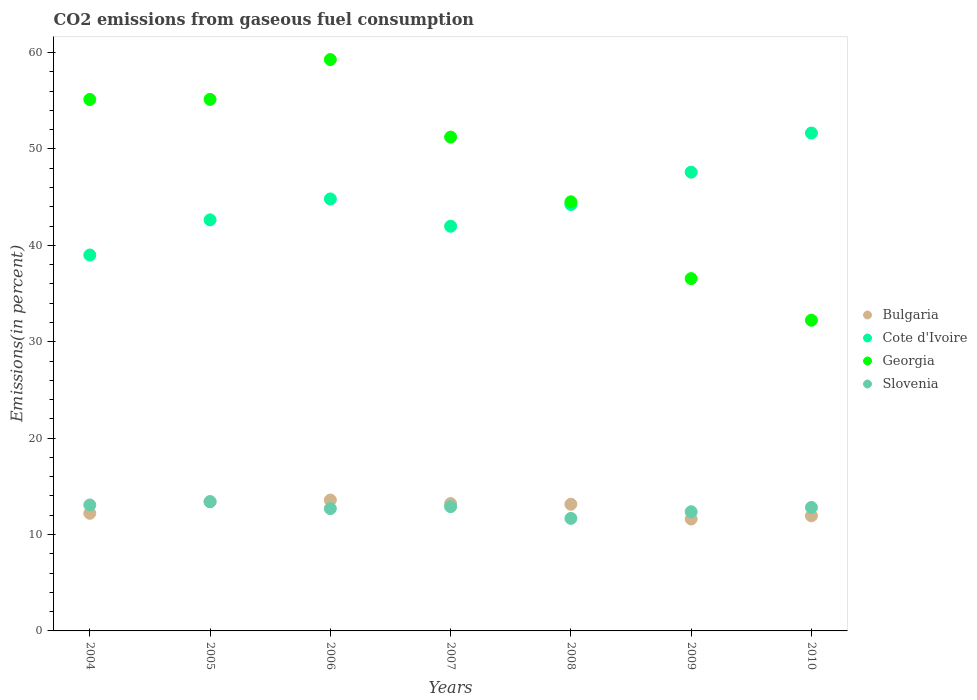What is the total CO2 emitted in Georgia in 2010?
Your answer should be very brief. 32.23. Across all years, what is the maximum total CO2 emitted in Bulgaria?
Your response must be concise. 13.58. Across all years, what is the minimum total CO2 emitted in Slovenia?
Give a very brief answer. 11.67. In which year was the total CO2 emitted in Slovenia maximum?
Give a very brief answer. 2005. What is the total total CO2 emitted in Bulgaria in the graph?
Ensure brevity in your answer.  89.08. What is the difference between the total CO2 emitted in Georgia in 2004 and that in 2008?
Give a very brief answer. 10.62. What is the difference between the total CO2 emitted in Bulgaria in 2004 and the total CO2 emitted in Georgia in 2007?
Your answer should be compact. -39.02. What is the average total CO2 emitted in Cote d'Ivoire per year?
Provide a succinct answer. 44.56. In the year 2010, what is the difference between the total CO2 emitted in Slovenia and total CO2 emitted in Georgia?
Provide a succinct answer. -19.42. What is the ratio of the total CO2 emitted in Bulgaria in 2004 to that in 2010?
Your answer should be very brief. 1.02. Is the total CO2 emitted in Bulgaria in 2005 less than that in 2009?
Give a very brief answer. No. What is the difference between the highest and the second highest total CO2 emitted in Bulgaria?
Provide a succinct answer. 0.17. What is the difference between the highest and the lowest total CO2 emitted in Bulgaria?
Your response must be concise. 1.97. Is it the case that in every year, the sum of the total CO2 emitted in Bulgaria and total CO2 emitted in Georgia  is greater than the total CO2 emitted in Cote d'Ivoire?
Give a very brief answer. No. Is the total CO2 emitted in Cote d'Ivoire strictly less than the total CO2 emitted in Bulgaria over the years?
Provide a short and direct response. No. How many years are there in the graph?
Offer a terse response. 7. Does the graph contain grids?
Ensure brevity in your answer.  No. Where does the legend appear in the graph?
Offer a terse response. Center right. How many legend labels are there?
Offer a very short reply. 4. How are the legend labels stacked?
Offer a terse response. Vertical. What is the title of the graph?
Ensure brevity in your answer.  CO2 emissions from gaseous fuel consumption. Does "Greenland" appear as one of the legend labels in the graph?
Provide a succinct answer. No. What is the label or title of the Y-axis?
Give a very brief answer. Emissions(in percent). What is the Emissions(in percent) in Bulgaria in 2004?
Keep it short and to the point. 12.2. What is the Emissions(in percent) of Cote d'Ivoire in 2004?
Offer a very short reply. 39. What is the Emissions(in percent) in Georgia in 2004?
Offer a very short reply. 55.13. What is the Emissions(in percent) of Slovenia in 2004?
Your response must be concise. 13.06. What is the Emissions(in percent) of Bulgaria in 2005?
Offer a terse response. 13.4. What is the Emissions(in percent) in Cote d'Ivoire in 2005?
Your answer should be very brief. 42.64. What is the Emissions(in percent) of Georgia in 2005?
Keep it short and to the point. 55.14. What is the Emissions(in percent) of Slovenia in 2005?
Offer a very short reply. 13.4. What is the Emissions(in percent) in Bulgaria in 2006?
Keep it short and to the point. 13.58. What is the Emissions(in percent) of Cote d'Ivoire in 2006?
Keep it short and to the point. 44.81. What is the Emissions(in percent) in Georgia in 2006?
Your response must be concise. 59.27. What is the Emissions(in percent) of Slovenia in 2006?
Make the answer very short. 12.69. What is the Emissions(in percent) in Bulgaria in 2007?
Your answer should be very brief. 13.21. What is the Emissions(in percent) in Cote d'Ivoire in 2007?
Ensure brevity in your answer.  41.98. What is the Emissions(in percent) of Georgia in 2007?
Offer a very short reply. 51.23. What is the Emissions(in percent) of Slovenia in 2007?
Make the answer very short. 12.89. What is the Emissions(in percent) of Bulgaria in 2008?
Give a very brief answer. 13.14. What is the Emissions(in percent) of Cote d'Ivoire in 2008?
Offer a very short reply. 44.24. What is the Emissions(in percent) in Georgia in 2008?
Provide a short and direct response. 44.51. What is the Emissions(in percent) of Slovenia in 2008?
Make the answer very short. 11.67. What is the Emissions(in percent) of Bulgaria in 2009?
Provide a short and direct response. 11.61. What is the Emissions(in percent) of Cote d'Ivoire in 2009?
Offer a very short reply. 47.59. What is the Emissions(in percent) in Georgia in 2009?
Make the answer very short. 36.55. What is the Emissions(in percent) of Slovenia in 2009?
Ensure brevity in your answer.  12.36. What is the Emissions(in percent) in Bulgaria in 2010?
Your response must be concise. 11.94. What is the Emissions(in percent) of Cote d'Ivoire in 2010?
Your answer should be very brief. 51.65. What is the Emissions(in percent) in Georgia in 2010?
Provide a succinct answer. 32.23. What is the Emissions(in percent) in Slovenia in 2010?
Your response must be concise. 12.81. Across all years, what is the maximum Emissions(in percent) of Bulgaria?
Offer a very short reply. 13.58. Across all years, what is the maximum Emissions(in percent) in Cote d'Ivoire?
Offer a very short reply. 51.65. Across all years, what is the maximum Emissions(in percent) in Georgia?
Offer a terse response. 59.27. Across all years, what is the maximum Emissions(in percent) in Slovenia?
Ensure brevity in your answer.  13.4. Across all years, what is the minimum Emissions(in percent) of Bulgaria?
Keep it short and to the point. 11.61. Across all years, what is the minimum Emissions(in percent) of Cote d'Ivoire?
Ensure brevity in your answer.  39. Across all years, what is the minimum Emissions(in percent) in Georgia?
Give a very brief answer. 32.23. Across all years, what is the minimum Emissions(in percent) in Slovenia?
Ensure brevity in your answer.  11.67. What is the total Emissions(in percent) in Bulgaria in the graph?
Keep it short and to the point. 89.08. What is the total Emissions(in percent) of Cote d'Ivoire in the graph?
Your response must be concise. 311.91. What is the total Emissions(in percent) in Georgia in the graph?
Keep it short and to the point. 334.06. What is the total Emissions(in percent) of Slovenia in the graph?
Offer a very short reply. 88.89. What is the difference between the Emissions(in percent) of Bulgaria in 2004 and that in 2005?
Offer a very short reply. -1.2. What is the difference between the Emissions(in percent) of Cote d'Ivoire in 2004 and that in 2005?
Ensure brevity in your answer.  -3.65. What is the difference between the Emissions(in percent) of Georgia in 2004 and that in 2005?
Provide a short and direct response. -0.01. What is the difference between the Emissions(in percent) in Slovenia in 2004 and that in 2005?
Provide a succinct answer. -0.34. What is the difference between the Emissions(in percent) in Bulgaria in 2004 and that in 2006?
Your response must be concise. -1.37. What is the difference between the Emissions(in percent) of Cote d'Ivoire in 2004 and that in 2006?
Provide a short and direct response. -5.82. What is the difference between the Emissions(in percent) of Georgia in 2004 and that in 2006?
Your answer should be very brief. -4.14. What is the difference between the Emissions(in percent) in Slovenia in 2004 and that in 2006?
Provide a succinct answer. 0.38. What is the difference between the Emissions(in percent) in Bulgaria in 2004 and that in 2007?
Offer a terse response. -1.01. What is the difference between the Emissions(in percent) in Cote d'Ivoire in 2004 and that in 2007?
Provide a short and direct response. -2.99. What is the difference between the Emissions(in percent) in Georgia in 2004 and that in 2007?
Make the answer very short. 3.9. What is the difference between the Emissions(in percent) in Slovenia in 2004 and that in 2007?
Offer a very short reply. 0.18. What is the difference between the Emissions(in percent) in Bulgaria in 2004 and that in 2008?
Keep it short and to the point. -0.94. What is the difference between the Emissions(in percent) in Cote d'Ivoire in 2004 and that in 2008?
Make the answer very short. -5.24. What is the difference between the Emissions(in percent) of Georgia in 2004 and that in 2008?
Offer a terse response. 10.62. What is the difference between the Emissions(in percent) in Slovenia in 2004 and that in 2008?
Offer a very short reply. 1.39. What is the difference between the Emissions(in percent) in Bulgaria in 2004 and that in 2009?
Provide a succinct answer. 0.6. What is the difference between the Emissions(in percent) in Cote d'Ivoire in 2004 and that in 2009?
Ensure brevity in your answer.  -8.59. What is the difference between the Emissions(in percent) of Georgia in 2004 and that in 2009?
Give a very brief answer. 18.58. What is the difference between the Emissions(in percent) in Slovenia in 2004 and that in 2009?
Make the answer very short. 0.7. What is the difference between the Emissions(in percent) in Bulgaria in 2004 and that in 2010?
Offer a terse response. 0.26. What is the difference between the Emissions(in percent) of Cote d'Ivoire in 2004 and that in 2010?
Keep it short and to the point. -12.66. What is the difference between the Emissions(in percent) in Georgia in 2004 and that in 2010?
Offer a terse response. 22.9. What is the difference between the Emissions(in percent) of Slovenia in 2004 and that in 2010?
Offer a very short reply. 0.25. What is the difference between the Emissions(in percent) of Bulgaria in 2005 and that in 2006?
Your answer should be compact. -0.17. What is the difference between the Emissions(in percent) of Cote d'Ivoire in 2005 and that in 2006?
Your answer should be compact. -2.17. What is the difference between the Emissions(in percent) in Georgia in 2005 and that in 2006?
Offer a very short reply. -4.13. What is the difference between the Emissions(in percent) of Slovenia in 2005 and that in 2006?
Your response must be concise. 0.72. What is the difference between the Emissions(in percent) in Bulgaria in 2005 and that in 2007?
Provide a short and direct response. 0.19. What is the difference between the Emissions(in percent) in Cote d'Ivoire in 2005 and that in 2007?
Your answer should be very brief. 0.66. What is the difference between the Emissions(in percent) of Georgia in 2005 and that in 2007?
Your answer should be compact. 3.91. What is the difference between the Emissions(in percent) in Slovenia in 2005 and that in 2007?
Make the answer very short. 0.51. What is the difference between the Emissions(in percent) in Bulgaria in 2005 and that in 2008?
Your response must be concise. 0.26. What is the difference between the Emissions(in percent) in Cote d'Ivoire in 2005 and that in 2008?
Ensure brevity in your answer.  -1.59. What is the difference between the Emissions(in percent) in Georgia in 2005 and that in 2008?
Your answer should be compact. 10.62. What is the difference between the Emissions(in percent) of Slovenia in 2005 and that in 2008?
Your answer should be compact. 1.73. What is the difference between the Emissions(in percent) in Bulgaria in 2005 and that in 2009?
Offer a terse response. 1.8. What is the difference between the Emissions(in percent) of Cote d'Ivoire in 2005 and that in 2009?
Provide a succinct answer. -4.95. What is the difference between the Emissions(in percent) in Georgia in 2005 and that in 2009?
Your answer should be compact. 18.59. What is the difference between the Emissions(in percent) in Slovenia in 2005 and that in 2009?
Give a very brief answer. 1.04. What is the difference between the Emissions(in percent) of Bulgaria in 2005 and that in 2010?
Offer a very short reply. 1.46. What is the difference between the Emissions(in percent) of Cote d'Ivoire in 2005 and that in 2010?
Your answer should be very brief. -9.01. What is the difference between the Emissions(in percent) of Georgia in 2005 and that in 2010?
Offer a very short reply. 22.91. What is the difference between the Emissions(in percent) of Slovenia in 2005 and that in 2010?
Offer a terse response. 0.59. What is the difference between the Emissions(in percent) of Bulgaria in 2006 and that in 2007?
Make the answer very short. 0.37. What is the difference between the Emissions(in percent) of Cote d'Ivoire in 2006 and that in 2007?
Keep it short and to the point. 2.83. What is the difference between the Emissions(in percent) in Georgia in 2006 and that in 2007?
Keep it short and to the point. 8.04. What is the difference between the Emissions(in percent) in Slovenia in 2006 and that in 2007?
Your response must be concise. -0.2. What is the difference between the Emissions(in percent) of Bulgaria in 2006 and that in 2008?
Give a very brief answer. 0.44. What is the difference between the Emissions(in percent) of Cote d'Ivoire in 2006 and that in 2008?
Ensure brevity in your answer.  0.57. What is the difference between the Emissions(in percent) of Georgia in 2006 and that in 2008?
Your answer should be very brief. 14.76. What is the difference between the Emissions(in percent) of Slovenia in 2006 and that in 2008?
Give a very brief answer. 1.01. What is the difference between the Emissions(in percent) of Bulgaria in 2006 and that in 2009?
Your answer should be very brief. 1.97. What is the difference between the Emissions(in percent) in Cote d'Ivoire in 2006 and that in 2009?
Ensure brevity in your answer.  -2.78. What is the difference between the Emissions(in percent) in Georgia in 2006 and that in 2009?
Your answer should be compact. 22.72. What is the difference between the Emissions(in percent) in Slovenia in 2006 and that in 2009?
Offer a terse response. 0.32. What is the difference between the Emissions(in percent) of Bulgaria in 2006 and that in 2010?
Your answer should be very brief. 1.63. What is the difference between the Emissions(in percent) of Cote d'Ivoire in 2006 and that in 2010?
Provide a short and direct response. -6.84. What is the difference between the Emissions(in percent) of Georgia in 2006 and that in 2010?
Ensure brevity in your answer.  27.04. What is the difference between the Emissions(in percent) in Slovenia in 2006 and that in 2010?
Your answer should be compact. -0.13. What is the difference between the Emissions(in percent) in Bulgaria in 2007 and that in 2008?
Provide a succinct answer. 0.07. What is the difference between the Emissions(in percent) of Cote d'Ivoire in 2007 and that in 2008?
Your answer should be very brief. -2.25. What is the difference between the Emissions(in percent) of Georgia in 2007 and that in 2008?
Offer a terse response. 6.71. What is the difference between the Emissions(in percent) of Slovenia in 2007 and that in 2008?
Provide a succinct answer. 1.22. What is the difference between the Emissions(in percent) in Bulgaria in 2007 and that in 2009?
Ensure brevity in your answer.  1.6. What is the difference between the Emissions(in percent) of Cote d'Ivoire in 2007 and that in 2009?
Give a very brief answer. -5.61. What is the difference between the Emissions(in percent) of Georgia in 2007 and that in 2009?
Ensure brevity in your answer.  14.68. What is the difference between the Emissions(in percent) of Slovenia in 2007 and that in 2009?
Your response must be concise. 0.53. What is the difference between the Emissions(in percent) in Bulgaria in 2007 and that in 2010?
Offer a terse response. 1.27. What is the difference between the Emissions(in percent) of Cote d'Ivoire in 2007 and that in 2010?
Your response must be concise. -9.67. What is the difference between the Emissions(in percent) in Georgia in 2007 and that in 2010?
Offer a very short reply. 19. What is the difference between the Emissions(in percent) of Slovenia in 2007 and that in 2010?
Give a very brief answer. 0.08. What is the difference between the Emissions(in percent) in Bulgaria in 2008 and that in 2009?
Give a very brief answer. 1.53. What is the difference between the Emissions(in percent) in Cote d'Ivoire in 2008 and that in 2009?
Your response must be concise. -3.35. What is the difference between the Emissions(in percent) of Georgia in 2008 and that in 2009?
Your answer should be very brief. 7.96. What is the difference between the Emissions(in percent) of Slovenia in 2008 and that in 2009?
Your response must be concise. -0.69. What is the difference between the Emissions(in percent) of Bulgaria in 2008 and that in 2010?
Your response must be concise. 1.2. What is the difference between the Emissions(in percent) of Cote d'Ivoire in 2008 and that in 2010?
Ensure brevity in your answer.  -7.41. What is the difference between the Emissions(in percent) in Georgia in 2008 and that in 2010?
Give a very brief answer. 12.29. What is the difference between the Emissions(in percent) in Slovenia in 2008 and that in 2010?
Ensure brevity in your answer.  -1.14. What is the difference between the Emissions(in percent) in Bulgaria in 2009 and that in 2010?
Offer a very short reply. -0.34. What is the difference between the Emissions(in percent) of Cote d'Ivoire in 2009 and that in 2010?
Keep it short and to the point. -4.06. What is the difference between the Emissions(in percent) of Georgia in 2009 and that in 2010?
Provide a short and direct response. 4.32. What is the difference between the Emissions(in percent) of Slovenia in 2009 and that in 2010?
Offer a terse response. -0.45. What is the difference between the Emissions(in percent) in Bulgaria in 2004 and the Emissions(in percent) in Cote d'Ivoire in 2005?
Provide a short and direct response. -30.44. What is the difference between the Emissions(in percent) in Bulgaria in 2004 and the Emissions(in percent) in Georgia in 2005?
Provide a short and direct response. -42.93. What is the difference between the Emissions(in percent) in Bulgaria in 2004 and the Emissions(in percent) in Slovenia in 2005?
Keep it short and to the point. -1.2. What is the difference between the Emissions(in percent) of Cote d'Ivoire in 2004 and the Emissions(in percent) of Georgia in 2005?
Your answer should be compact. -16.14. What is the difference between the Emissions(in percent) of Cote d'Ivoire in 2004 and the Emissions(in percent) of Slovenia in 2005?
Your answer should be very brief. 25.59. What is the difference between the Emissions(in percent) of Georgia in 2004 and the Emissions(in percent) of Slovenia in 2005?
Keep it short and to the point. 41.73. What is the difference between the Emissions(in percent) of Bulgaria in 2004 and the Emissions(in percent) of Cote d'Ivoire in 2006?
Offer a very short reply. -32.61. What is the difference between the Emissions(in percent) of Bulgaria in 2004 and the Emissions(in percent) of Georgia in 2006?
Offer a terse response. -47.07. What is the difference between the Emissions(in percent) in Bulgaria in 2004 and the Emissions(in percent) in Slovenia in 2006?
Offer a terse response. -0.48. What is the difference between the Emissions(in percent) of Cote d'Ivoire in 2004 and the Emissions(in percent) of Georgia in 2006?
Keep it short and to the point. -20.28. What is the difference between the Emissions(in percent) of Cote d'Ivoire in 2004 and the Emissions(in percent) of Slovenia in 2006?
Your response must be concise. 26.31. What is the difference between the Emissions(in percent) in Georgia in 2004 and the Emissions(in percent) in Slovenia in 2006?
Keep it short and to the point. 42.45. What is the difference between the Emissions(in percent) in Bulgaria in 2004 and the Emissions(in percent) in Cote d'Ivoire in 2007?
Offer a terse response. -29.78. What is the difference between the Emissions(in percent) in Bulgaria in 2004 and the Emissions(in percent) in Georgia in 2007?
Keep it short and to the point. -39.02. What is the difference between the Emissions(in percent) of Bulgaria in 2004 and the Emissions(in percent) of Slovenia in 2007?
Keep it short and to the point. -0.69. What is the difference between the Emissions(in percent) of Cote d'Ivoire in 2004 and the Emissions(in percent) of Georgia in 2007?
Offer a very short reply. -12.23. What is the difference between the Emissions(in percent) of Cote d'Ivoire in 2004 and the Emissions(in percent) of Slovenia in 2007?
Provide a short and direct response. 26.11. What is the difference between the Emissions(in percent) of Georgia in 2004 and the Emissions(in percent) of Slovenia in 2007?
Your answer should be compact. 42.24. What is the difference between the Emissions(in percent) of Bulgaria in 2004 and the Emissions(in percent) of Cote d'Ivoire in 2008?
Keep it short and to the point. -32.03. What is the difference between the Emissions(in percent) of Bulgaria in 2004 and the Emissions(in percent) of Georgia in 2008?
Offer a terse response. -32.31. What is the difference between the Emissions(in percent) of Bulgaria in 2004 and the Emissions(in percent) of Slovenia in 2008?
Your response must be concise. 0.53. What is the difference between the Emissions(in percent) in Cote d'Ivoire in 2004 and the Emissions(in percent) in Georgia in 2008?
Make the answer very short. -5.52. What is the difference between the Emissions(in percent) of Cote d'Ivoire in 2004 and the Emissions(in percent) of Slovenia in 2008?
Your response must be concise. 27.32. What is the difference between the Emissions(in percent) of Georgia in 2004 and the Emissions(in percent) of Slovenia in 2008?
Your response must be concise. 43.46. What is the difference between the Emissions(in percent) of Bulgaria in 2004 and the Emissions(in percent) of Cote d'Ivoire in 2009?
Your answer should be compact. -35.39. What is the difference between the Emissions(in percent) in Bulgaria in 2004 and the Emissions(in percent) in Georgia in 2009?
Ensure brevity in your answer.  -24.35. What is the difference between the Emissions(in percent) of Bulgaria in 2004 and the Emissions(in percent) of Slovenia in 2009?
Offer a very short reply. -0.16. What is the difference between the Emissions(in percent) in Cote d'Ivoire in 2004 and the Emissions(in percent) in Georgia in 2009?
Your answer should be very brief. 2.45. What is the difference between the Emissions(in percent) of Cote d'Ivoire in 2004 and the Emissions(in percent) of Slovenia in 2009?
Ensure brevity in your answer.  26.63. What is the difference between the Emissions(in percent) of Georgia in 2004 and the Emissions(in percent) of Slovenia in 2009?
Give a very brief answer. 42.77. What is the difference between the Emissions(in percent) in Bulgaria in 2004 and the Emissions(in percent) in Cote d'Ivoire in 2010?
Provide a succinct answer. -39.45. What is the difference between the Emissions(in percent) of Bulgaria in 2004 and the Emissions(in percent) of Georgia in 2010?
Your answer should be compact. -20.03. What is the difference between the Emissions(in percent) of Bulgaria in 2004 and the Emissions(in percent) of Slovenia in 2010?
Keep it short and to the point. -0.61. What is the difference between the Emissions(in percent) in Cote d'Ivoire in 2004 and the Emissions(in percent) in Georgia in 2010?
Provide a short and direct response. 6.77. What is the difference between the Emissions(in percent) in Cote d'Ivoire in 2004 and the Emissions(in percent) in Slovenia in 2010?
Keep it short and to the point. 26.18. What is the difference between the Emissions(in percent) in Georgia in 2004 and the Emissions(in percent) in Slovenia in 2010?
Your response must be concise. 42.32. What is the difference between the Emissions(in percent) in Bulgaria in 2005 and the Emissions(in percent) in Cote d'Ivoire in 2006?
Your answer should be compact. -31.41. What is the difference between the Emissions(in percent) in Bulgaria in 2005 and the Emissions(in percent) in Georgia in 2006?
Provide a succinct answer. -45.87. What is the difference between the Emissions(in percent) of Bulgaria in 2005 and the Emissions(in percent) of Slovenia in 2006?
Keep it short and to the point. 0.72. What is the difference between the Emissions(in percent) of Cote d'Ivoire in 2005 and the Emissions(in percent) of Georgia in 2006?
Provide a short and direct response. -16.63. What is the difference between the Emissions(in percent) of Cote d'Ivoire in 2005 and the Emissions(in percent) of Slovenia in 2006?
Provide a short and direct response. 29.96. What is the difference between the Emissions(in percent) of Georgia in 2005 and the Emissions(in percent) of Slovenia in 2006?
Keep it short and to the point. 42.45. What is the difference between the Emissions(in percent) in Bulgaria in 2005 and the Emissions(in percent) in Cote d'Ivoire in 2007?
Provide a short and direct response. -28.58. What is the difference between the Emissions(in percent) in Bulgaria in 2005 and the Emissions(in percent) in Georgia in 2007?
Give a very brief answer. -37.83. What is the difference between the Emissions(in percent) in Bulgaria in 2005 and the Emissions(in percent) in Slovenia in 2007?
Your response must be concise. 0.51. What is the difference between the Emissions(in percent) of Cote d'Ivoire in 2005 and the Emissions(in percent) of Georgia in 2007?
Provide a succinct answer. -8.58. What is the difference between the Emissions(in percent) of Cote d'Ivoire in 2005 and the Emissions(in percent) of Slovenia in 2007?
Provide a short and direct response. 29.75. What is the difference between the Emissions(in percent) in Georgia in 2005 and the Emissions(in percent) in Slovenia in 2007?
Your response must be concise. 42.25. What is the difference between the Emissions(in percent) in Bulgaria in 2005 and the Emissions(in percent) in Cote d'Ivoire in 2008?
Your answer should be very brief. -30.83. What is the difference between the Emissions(in percent) of Bulgaria in 2005 and the Emissions(in percent) of Georgia in 2008?
Offer a terse response. -31.11. What is the difference between the Emissions(in percent) of Bulgaria in 2005 and the Emissions(in percent) of Slovenia in 2008?
Ensure brevity in your answer.  1.73. What is the difference between the Emissions(in percent) in Cote d'Ivoire in 2005 and the Emissions(in percent) in Georgia in 2008?
Provide a short and direct response. -1.87. What is the difference between the Emissions(in percent) in Cote d'Ivoire in 2005 and the Emissions(in percent) in Slovenia in 2008?
Ensure brevity in your answer.  30.97. What is the difference between the Emissions(in percent) of Georgia in 2005 and the Emissions(in percent) of Slovenia in 2008?
Your answer should be very brief. 43.46. What is the difference between the Emissions(in percent) of Bulgaria in 2005 and the Emissions(in percent) of Cote d'Ivoire in 2009?
Keep it short and to the point. -34.19. What is the difference between the Emissions(in percent) of Bulgaria in 2005 and the Emissions(in percent) of Georgia in 2009?
Provide a short and direct response. -23.15. What is the difference between the Emissions(in percent) of Bulgaria in 2005 and the Emissions(in percent) of Slovenia in 2009?
Provide a short and direct response. 1.04. What is the difference between the Emissions(in percent) of Cote d'Ivoire in 2005 and the Emissions(in percent) of Georgia in 2009?
Keep it short and to the point. 6.09. What is the difference between the Emissions(in percent) in Cote d'Ivoire in 2005 and the Emissions(in percent) in Slovenia in 2009?
Keep it short and to the point. 30.28. What is the difference between the Emissions(in percent) in Georgia in 2005 and the Emissions(in percent) in Slovenia in 2009?
Your answer should be very brief. 42.77. What is the difference between the Emissions(in percent) in Bulgaria in 2005 and the Emissions(in percent) in Cote d'Ivoire in 2010?
Your response must be concise. -38.25. What is the difference between the Emissions(in percent) in Bulgaria in 2005 and the Emissions(in percent) in Georgia in 2010?
Make the answer very short. -18.83. What is the difference between the Emissions(in percent) of Bulgaria in 2005 and the Emissions(in percent) of Slovenia in 2010?
Keep it short and to the point. 0.59. What is the difference between the Emissions(in percent) in Cote d'Ivoire in 2005 and the Emissions(in percent) in Georgia in 2010?
Ensure brevity in your answer.  10.41. What is the difference between the Emissions(in percent) in Cote d'Ivoire in 2005 and the Emissions(in percent) in Slovenia in 2010?
Provide a short and direct response. 29.83. What is the difference between the Emissions(in percent) in Georgia in 2005 and the Emissions(in percent) in Slovenia in 2010?
Offer a very short reply. 42.33. What is the difference between the Emissions(in percent) of Bulgaria in 2006 and the Emissions(in percent) of Cote d'Ivoire in 2007?
Offer a terse response. -28.41. What is the difference between the Emissions(in percent) in Bulgaria in 2006 and the Emissions(in percent) in Georgia in 2007?
Offer a very short reply. -37.65. What is the difference between the Emissions(in percent) of Bulgaria in 2006 and the Emissions(in percent) of Slovenia in 2007?
Offer a very short reply. 0.69. What is the difference between the Emissions(in percent) in Cote d'Ivoire in 2006 and the Emissions(in percent) in Georgia in 2007?
Provide a succinct answer. -6.42. What is the difference between the Emissions(in percent) in Cote d'Ivoire in 2006 and the Emissions(in percent) in Slovenia in 2007?
Provide a short and direct response. 31.92. What is the difference between the Emissions(in percent) in Georgia in 2006 and the Emissions(in percent) in Slovenia in 2007?
Offer a very short reply. 46.38. What is the difference between the Emissions(in percent) of Bulgaria in 2006 and the Emissions(in percent) of Cote d'Ivoire in 2008?
Keep it short and to the point. -30.66. What is the difference between the Emissions(in percent) in Bulgaria in 2006 and the Emissions(in percent) in Georgia in 2008?
Your response must be concise. -30.94. What is the difference between the Emissions(in percent) in Bulgaria in 2006 and the Emissions(in percent) in Slovenia in 2008?
Your answer should be compact. 1.9. What is the difference between the Emissions(in percent) in Cote d'Ivoire in 2006 and the Emissions(in percent) in Georgia in 2008?
Make the answer very short. 0.3. What is the difference between the Emissions(in percent) in Cote d'Ivoire in 2006 and the Emissions(in percent) in Slovenia in 2008?
Your answer should be compact. 33.14. What is the difference between the Emissions(in percent) in Georgia in 2006 and the Emissions(in percent) in Slovenia in 2008?
Give a very brief answer. 47.6. What is the difference between the Emissions(in percent) in Bulgaria in 2006 and the Emissions(in percent) in Cote d'Ivoire in 2009?
Offer a terse response. -34.01. What is the difference between the Emissions(in percent) of Bulgaria in 2006 and the Emissions(in percent) of Georgia in 2009?
Keep it short and to the point. -22.97. What is the difference between the Emissions(in percent) of Bulgaria in 2006 and the Emissions(in percent) of Slovenia in 2009?
Your response must be concise. 1.21. What is the difference between the Emissions(in percent) in Cote d'Ivoire in 2006 and the Emissions(in percent) in Georgia in 2009?
Provide a short and direct response. 8.26. What is the difference between the Emissions(in percent) of Cote d'Ivoire in 2006 and the Emissions(in percent) of Slovenia in 2009?
Your response must be concise. 32.45. What is the difference between the Emissions(in percent) of Georgia in 2006 and the Emissions(in percent) of Slovenia in 2009?
Your answer should be compact. 46.91. What is the difference between the Emissions(in percent) of Bulgaria in 2006 and the Emissions(in percent) of Cote d'Ivoire in 2010?
Make the answer very short. -38.08. What is the difference between the Emissions(in percent) in Bulgaria in 2006 and the Emissions(in percent) in Georgia in 2010?
Ensure brevity in your answer.  -18.65. What is the difference between the Emissions(in percent) of Bulgaria in 2006 and the Emissions(in percent) of Slovenia in 2010?
Your answer should be very brief. 0.76. What is the difference between the Emissions(in percent) of Cote d'Ivoire in 2006 and the Emissions(in percent) of Georgia in 2010?
Keep it short and to the point. 12.58. What is the difference between the Emissions(in percent) in Cote d'Ivoire in 2006 and the Emissions(in percent) in Slovenia in 2010?
Make the answer very short. 32. What is the difference between the Emissions(in percent) in Georgia in 2006 and the Emissions(in percent) in Slovenia in 2010?
Give a very brief answer. 46.46. What is the difference between the Emissions(in percent) of Bulgaria in 2007 and the Emissions(in percent) of Cote d'Ivoire in 2008?
Offer a very short reply. -31.03. What is the difference between the Emissions(in percent) in Bulgaria in 2007 and the Emissions(in percent) in Georgia in 2008?
Make the answer very short. -31.3. What is the difference between the Emissions(in percent) in Bulgaria in 2007 and the Emissions(in percent) in Slovenia in 2008?
Offer a terse response. 1.54. What is the difference between the Emissions(in percent) in Cote d'Ivoire in 2007 and the Emissions(in percent) in Georgia in 2008?
Make the answer very short. -2.53. What is the difference between the Emissions(in percent) in Cote d'Ivoire in 2007 and the Emissions(in percent) in Slovenia in 2008?
Keep it short and to the point. 30.31. What is the difference between the Emissions(in percent) of Georgia in 2007 and the Emissions(in percent) of Slovenia in 2008?
Provide a succinct answer. 39.55. What is the difference between the Emissions(in percent) of Bulgaria in 2007 and the Emissions(in percent) of Cote d'Ivoire in 2009?
Make the answer very short. -34.38. What is the difference between the Emissions(in percent) in Bulgaria in 2007 and the Emissions(in percent) in Georgia in 2009?
Give a very brief answer. -23.34. What is the difference between the Emissions(in percent) in Bulgaria in 2007 and the Emissions(in percent) in Slovenia in 2009?
Your answer should be very brief. 0.85. What is the difference between the Emissions(in percent) in Cote d'Ivoire in 2007 and the Emissions(in percent) in Georgia in 2009?
Your answer should be very brief. 5.43. What is the difference between the Emissions(in percent) of Cote d'Ivoire in 2007 and the Emissions(in percent) of Slovenia in 2009?
Provide a succinct answer. 29.62. What is the difference between the Emissions(in percent) in Georgia in 2007 and the Emissions(in percent) in Slovenia in 2009?
Your answer should be compact. 38.86. What is the difference between the Emissions(in percent) of Bulgaria in 2007 and the Emissions(in percent) of Cote d'Ivoire in 2010?
Ensure brevity in your answer.  -38.44. What is the difference between the Emissions(in percent) of Bulgaria in 2007 and the Emissions(in percent) of Georgia in 2010?
Provide a short and direct response. -19.02. What is the difference between the Emissions(in percent) of Bulgaria in 2007 and the Emissions(in percent) of Slovenia in 2010?
Provide a short and direct response. 0.4. What is the difference between the Emissions(in percent) in Cote d'Ivoire in 2007 and the Emissions(in percent) in Georgia in 2010?
Offer a terse response. 9.75. What is the difference between the Emissions(in percent) in Cote d'Ivoire in 2007 and the Emissions(in percent) in Slovenia in 2010?
Ensure brevity in your answer.  29.17. What is the difference between the Emissions(in percent) of Georgia in 2007 and the Emissions(in percent) of Slovenia in 2010?
Provide a succinct answer. 38.42. What is the difference between the Emissions(in percent) in Bulgaria in 2008 and the Emissions(in percent) in Cote d'Ivoire in 2009?
Your answer should be compact. -34.45. What is the difference between the Emissions(in percent) in Bulgaria in 2008 and the Emissions(in percent) in Georgia in 2009?
Your response must be concise. -23.41. What is the difference between the Emissions(in percent) in Bulgaria in 2008 and the Emissions(in percent) in Slovenia in 2009?
Keep it short and to the point. 0.78. What is the difference between the Emissions(in percent) of Cote d'Ivoire in 2008 and the Emissions(in percent) of Georgia in 2009?
Provide a succinct answer. 7.69. What is the difference between the Emissions(in percent) in Cote d'Ivoire in 2008 and the Emissions(in percent) in Slovenia in 2009?
Your answer should be compact. 31.87. What is the difference between the Emissions(in percent) in Georgia in 2008 and the Emissions(in percent) in Slovenia in 2009?
Make the answer very short. 32.15. What is the difference between the Emissions(in percent) in Bulgaria in 2008 and the Emissions(in percent) in Cote d'Ivoire in 2010?
Provide a succinct answer. -38.51. What is the difference between the Emissions(in percent) in Bulgaria in 2008 and the Emissions(in percent) in Georgia in 2010?
Your answer should be compact. -19.09. What is the difference between the Emissions(in percent) in Bulgaria in 2008 and the Emissions(in percent) in Slovenia in 2010?
Offer a very short reply. 0.33. What is the difference between the Emissions(in percent) of Cote d'Ivoire in 2008 and the Emissions(in percent) of Georgia in 2010?
Offer a very short reply. 12.01. What is the difference between the Emissions(in percent) in Cote d'Ivoire in 2008 and the Emissions(in percent) in Slovenia in 2010?
Make the answer very short. 31.42. What is the difference between the Emissions(in percent) of Georgia in 2008 and the Emissions(in percent) of Slovenia in 2010?
Keep it short and to the point. 31.7. What is the difference between the Emissions(in percent) in Bulgaria in 2009 and the Emissions(in percent) in Cote d'Ivoire in 2010?
Offer a terse response. -40.05. What is the difference between the Emissions(in percent) of Bulgaria in 2009 and the Emissions(in percent) of Georgia in 2010?
Give a very brief answer. -20.62. What is the difference between the Emissions(in percent) of Bulgaria in 2009 and the Emissions(in percent) of Slovenia in 2010?
Give a very brief answer. -1.21. What is the difference between the Emissions(in percent) of Cote d'Ivoire in 2009 and the Emissions(in percent) of Georgia in 2010?
Your answer should be compact. 15.36. What is the difference between the Emissions(in percent) of Cote d'Ivoire in 2009 and the Emissions(in percent) of Slovenia in 2010?
Provide a succinct answer. 34.78. What is the difference between the Emissions(in percent) of Georgia in 2009 and the Emissions(in percent) of Slovenia in 2010?
Provide a short and direct response. 23.74. What is the average Emissions(in percent) of Bulgaria per year?
Provide a succinct answer. 12.73. What is the average Emissions(in percent) of Cote d'Ivoire per year?
Your response must be concise. 44.56. What is the average Emissions(in percent) in Georgia per year?
Your answer should be compact. 47.72. What is the average Emissions(in percent) in Slovenia per year?
Make the answer very short. 12.7. In the year 2004, what is the difference between the Emissions(in percent) in Bulgaria and Emissions(in percent) in Cote d'Ivoire?
Your answer should be very brief. -26.79. In the year 2004, what is the difference between the Emissions(in percent) in Bulgaria and Emissions(in percent) in Georgia?
Offer a terse response. -42.93. In the year 2004, what is the difference between the Emissions(in percent) in Bulgaria and Emissions(in percent) in Slovenia?
Your answer should be very brief. -0.86. In the year 2004, what is the difference between the Emissions(in percent) of Cote d'Ivoire and Emissions(in percent) of Georgia?
Your response must be concise. -16.14. In the year 2004, what is the difference between the Emissions(in percent) in Cote d'Ivoire and Emissions(in percent) in Slovenia?
Ensure brevity in your answer.  25.93. In the year 2004, what is the difference between the Emissions(in percent) in Georgia and Emissions(in percent) in Slovenia?
Provide a succinct answer. 42.07. In the year 2005, what is the difference between the Emissions(in percent) in Bulgaria and Emissions(in percent) in Cote d'Ivoire?
Make the answer very short. -29.24. In the year 2005, what is the difference between the Emissions(in percent) in Bulgaria and Emissions(in percent) in Georgia?
Offer a very short reply. -41.74. In the year 2005, what is the difference between the Emissions(in percent) in Bulgaria and Emissions(in percent) in Slovenia?
Ensure brevity in your answer.  -0. In the year 2005, what is the difference between the Emissions(in percent) in Cote d'Ivoire and Emissions(in percent) in Georgia?
Offer a terse response. -12.49. In the year 2005, what is the difference between the Emissions(in percent) of Cote d'Ivoire and Emissions(in percent) of Slovenia?
Offer a very short reply. 29.24. In the year 2005, what is the difference between the Emissions(in percent) of Georgia and Emissions(in percent) of Slovenia?
Give a very brief answer. 41.73. In the year 2006, what is the difference between the Emissions(in percent) in Bulgaria and Emissions(in percent) in Cote d'Ivoire?
Keep it short and to the point. -31.24. In the year 2006, what is the difference between the Emissions(in percent) in Bulgaria and Emissions(in percent) in Georgia?
Your response must be concise. -45.7. In the year 2006, what is the difference between the Emissions(in percent) in Bulgaria and Emissions(in percent) in Slovenia?
Your answer should be compact. 0.89. In the year 2006, what is the difference between the Emissions(in percent) of Cote d'Ivoire and Emissions(in percent) of Georgia?
Your answer should be very brief. -14.46. In the year 2006, what is the difference between the Emissions(in percent) of Cote d'Ivoire and Emissions(in percent) of Slovenia?
Make the answer very short. 32.13. In the year 2006, what is the difference between the Emissions(in percent) of Georgia and Emissions(in percent) of Slovenia?
Provide a succinct answer. 46.59. In the year 2007, what is the difference between the Emissions(in percent) in Bulgaria and Emissions(in percent) in Cote d'Ivoire?
Your answer should be very brief. -28.77. In the year 2007, what is the difference between the Emissions(in percent) in Bulgaria and Emissions(in percent) in Georgia?
Offer a terse response. -38.02. In the year 2007, what is the difference between the Emissions(in percent) of Bulgaria and Emissions(in percent) of Slovenia?
Provide a short and direct response. 0.32. In the year 2007, what is the difference between the Emissions(in percent) of Cote d'Ivoire and Emissions(in percent) of Georgia?
Offer a terse response. -9.25. In the year 2007, what is the difference between the Emissions(in percent) in Cote d'Ivoire and Emissions(in percent) in Slovenia?
Offer a terse response. 29.09. In the year 2007, what is the difference between the Emissions(in percent) in Georgia and Emissions(in percent) in Slovenia?
Make the answer very short. 38.34. In the year 2008, what is the difference between the Emissions(in percent) in Bulgaria and Emissions(in percent) in Cote d'Ivoire?
Your answer should be very brief. -31.1. In the year 2008, what is the difference between the Emissions(in percent) of Bulgaria and Emissions(in percent) of Georgia?
Ensure brevity in your answer.  -31.37. In the year 2008, what is the difference between the Emissions(in percent) of Bulgaria and Emissions(in percent) of Slovenia?
Provide a short and direct response. 1.47. In the year 2008, what is the difference between the Emissions(in percent) in Cote d'Ivoire and Emissions(in percent) in Georgia?
Provide a succinct answer. -0.28. In the year 2008, what is the difference between the Emissions(in percent) of Cote d'Ivoire and Emissions(in percent) of Slovenia?
Keep it short and to the point. 32.56. In the year 2008, what is the difference between the Emissions(in percent) in Georgia and Emissions(in percent) in Slovenia?
Provide a short and direct response. 32.84. In the year 2009, what is the difference between the Emissions(in percent) of Bulgaria and Emissions(in percent) of Cote d'Ivoire?
Your response must be concise. -35.98. In the year 2009, what is the difference between the Emissions(in percent) of Bulgaria and Emissions(in percent) of Georgia?
Provide a succinct answer. -24.94. In the year 2009, what is the difference between the Emissions(in percent) in Bulgaria and Emissions(in percent) in Slovenia?
Your response must be concise. -0.76. In the year 2009, what is the difference between the Emissions(in percent) of Cote d'Ivoire and Emissions(in percent) of Georgia?
Provide a succinct answer. 11.04. In the year 2009, what is the difference between the Emissions(in percent) of Cote d'Ivoire and Emissions(in percent) of Slovenia?
Offer a terse response. 35.23. In the year 2009, what is the difference between the Emissions(in percent) of Georgia and Emissions(in percent) of Slovenia?
Provide a short and direct response. 24.19. In the year 2010, what is the difference between the Emissions(in percent) of Bulgaria and Emissions(in percent) of Cote d'Ivoire?
Your response must be concise. -39.71. In the year 2010, what is the difference between the Emissions(in percent) of Bulgaria and Emissions(in percent) of Georgia?
Offer a very short reply. -20.29. In the year 2010, what is the difference between the Emissions(in percent) of Bulgaria and Emissions(in percent) of Slovenia?
Provide a short and direct response. -0.87. In the year 2010, what is the difference between the Emissions(in percent) in Cote d'Ivoire and Emissions(in percent) in Georgia?
Offer a terse response. 19.42. In the year 2010, what is the difference between the Emissions(in percent) of Cote d'Ivoire and Emissions(in percent) of Slovenia?
Offer a terse response. 38.84. In the year 2010, what is the difference between the Emissions(in percent) in Georgia and Emissions(in percent) in Slovenia?
Provide a short and direct response. 19.42. What is the ratio of the Emissions(in percent) of Bulgaria in 2004 to that in 2005?
Provide a short and direct response. 0.91. What is the ratio of the Emissions(in percent) of Cote d'Ivoire in 2004 to that in 2005?
Ensure brevity in your answer.  0.91. What is the ratio of the Emissions(in percent) in Georgia in 2004 to that in 2005?
Your answer should be compact. 1. What is the ratio of the Emissions(in percent) in Slovenia in 2004 to that in 2005?
Keep it short and to the point. 0.97. What is the ratio of the Emissions(in percent) of Bulgaria in 2004 to that in 2006?
Your response must be concise. 0.9. What is the ratio of the Emissions(in percent) of Cote d'Ivoire in 2004 to that in 2006?
Provide a succinct answer. 0.87. What is the ratio of the Emissions(in percent) of Georgia in 2004 to that in 2006?
Ensure brevity in your answer.  0.93. What is the ratio of the Emissions(in percent) of Slovenia in 2004 to that in 2006?
Offer a very short reply. 1.03. What is the ratio of the Emissions(in percent) in Bulgaria in 2004 to that in 2007?
Provide a short and direct response. 0.92. What is the ratio of the Emissions(in percent) in Cote d'Ivoire in 2004 to that in 2007?
Provide a short and direct response. 0.93. What is the ratio of the Emissions(in percent) of Georgia in 2004 to that in 2007?
Offer a terse response. 1.08. What is the ratio of the Emissions(in percent) of Slovenia in 2004 to that in 2007?
Offer a very short reply. 1.01. What is the ratio of the Emissions(in percent) in Bulgaria in 2004 to that in 2008?
Give a very brief answer. 0.93. What is the ratio of the Emissions(in percent) in Cote d'Ivoire in 2004 to that in 2008?
Give a very brief answer. 0.88. What is the ratio of the Emissions(in percent) in Georgia in 2004 to that in 2008?
Offer a terse response. 1.24. What is the ratio of the Emissions(in percent) in Slovenia in 2004 to that in 2008?
Make the answer very short. 1.12. What is the ratio of the Emissions(in percent) of Bulgaria in 2004 to that in 2009?
Provide a succinct answer. 1.05. What is the ratio of the Emissions(in percent) in Cote d'Ivoire in 2004 to that in 2009?
Keep it short and to the point. 0.82. What is the ratio of the Emissions(in percent) in Georgia in 2004 to that in 2009?
Your answer should be compact. 1.51. What is the ratio of the Emissions(in percent) of Slovenia in 2004 to that in 2009?
Give a very brief answer. 1.06. What is the ratio of the Emissions(in percent) of Bulgaria in 2004 to that in 2010?
Give a very brief answer. 1.02. What is the ratio of the Emissions(in percent) of Cote d'Ivoire in 2004 to that in 2010?
Keep it short and to the point. 0.76. What is the ratio of the Emissions(in percent) of Georgia in 2004 to that in 2010?
Ensure brevity in your answer.  1.71. What is the ratio of the Emissions(in percent) of Slovenia in 2004 to that in 2010?
Keep it short and to the point. 1.02. What is the ratio of the Emissions(in percent) in Bulgaria in 2005 to that in 2006?
Ensure brevity in your answer.  0.99. What is the ratio of the Emissions(in percent) of Cote d'Ivoire in 2005 to that in 2006?
Your answer should be very brief. 0.95. What is the ratio of the Emissions(in percent) of Georgia in 2005 to that in 2006?
Your response must be concise. 0.93. What is the ratio of the Emissions(in percent) of Slovenia in 2005 to that in 2006?
Offer a terse response. 1.06. What is the ratio of the Emissions(in percent) of Bulgaria in 2005 to that in 2007?
Offer a very short reply. 1.01. What is the ratio of the Emissions(in percent) of Cote d'Ivoire in 2005 to that in 2007?
Give a very brief answer. 1.02. What is the ratio of the Emissions(in percent) in Georgia in 2005 to that in 2007?
Provide a short and direct response. 1.08. What is the ratio of the Emissions(in percent) of Slovenia in 2005 to that in 2007?
Your response must be concise. 1.04. What is the ratio of the Emissions(in percent) in Georgia in 2005 to that in 2008?
Offer a very short reply. 1.24. What is the ratio of the Emissions(in percent) of Slovenia in 2005 to that in 2008?
Offer a terse response. 1.15. What is the ratio of the Emissions(in percent) of Bulgaria in 2005 to that in 2009?
Your response must be concise. 1.15. What is the ratio of the Emissions(in percent) of Cote d'Ivoire in 2005 to that in 2009?
Your answer should be compact. 0.9. What is the ratio of the Emissions(in percent) of Georgia in 2005 to that in 2009?
Your answer should be very brief. 1.51. What is the ratio of the Emissions(in percent) of Slovenia in 2005 to that in 2009?
Make the answer very short. 1.08. What is the ratio of the Emissions(in percent) of Bulgaria in 2005 to that in 2010?
Your answer should be very brief. 1.12. What is the ratio of the Emissions(in percent) of Cote d'Ivoire in 2005 to that in 2010?
Your answer should be very brief. 0.83. What is the ratio of the Emissions(in percent) in Georgia in 2005 to that in 2010?
Your answer should be compact. 1.71. What is the ratio of the Emissions(in percent) in Slovenia in 2005 to that in 2010?
Your response must be concise. 1.05. What is the ratio of the Emissions(in percent) of Bulgaria in 2006 to that in 2007?
Offer a very short reply. 1.03. What is the ratio of the Emissions(in percent) of Cote d'Ivoire in 2006 to that in 2007?
Your answer should be very brief. 1.07. What is the ratio of the Emissions(in percent) in Georgia in 2006 to that in 2007?
Your response must be concise. 1.16. What is the ratio of the Emissions(in percent) of Slovenia in 2006 to that in 2007?
Provide a succinct answer. 0.98. What is the ratio of the Emissions(in percent) of Bulgaria in 2006 to that in 2008?
Provide a short and direct response. 1.03. What is the ratio of the Emissions(in percent) in Cote d'Ivoire in 2006 to that in 2008?
Provide a succinct answer. 1.01. What is the ratio of the Emissions(in percent) of Georgia in 2006 to that in 2008?
Your answer should be very brief. 1.33. What is the ratio of the Emissions(in percent) in Slovenia in 2006 to that in 2008?
Offer a very short reply. 1.09. What is the ratio of the Emissions(in percent) of Bulgaria in 2006 to that in 2009?
Provide a succinct answer. 1.17. What is the ratio of the Emissions(in percent) in Cote d'Ivoire in 2006 to that in 2009?
Ensure brevity in your answer.  0.94. What is the ratio of the Emissions(in percent) of Georgia in 2006 to that in 2009?
Your response must be concise. 1.62. What is the ratio of the Emissions(in percent) in Slovenia in 2006 to that in 2009?
Your answer should be very brief. 1.03. What is the ratio of the Emissions(in percent) in Bulgaria in 2006 to that in 2010?
Offer a terse response. 1.14. What is the ratio of the Emissions(in percent) in Cote d'Ivoire in 2006 to that in 2010?
Provide a short and direct response. 0.87. What is the ratio of the Emissions(in percent) in Georgia in 2006 to that in 2010?
Your answer should be very brief. 1.84. What is the ratio of the Emissions(in percent) of Slovenia in 2006 to that in 2010?
Your response must be concise. 0.99. What is the ratio of the Emissions(in percent) of Cote d'Ivoire in 2007 to that in 2008?
Offer a very short reply. 0.95. What is the ratio of the Emissions(in percent) in Georgia in 2007 to that in 2008?
Give a very brief answer. 1.15. What is the ratio of the Emissions(in percent) in Slovenia in 2007 to that in 2008?
Make the answer very short. 1.1. What is the ratio of the Emissions(in percent) in Bulgaria in 2007 to that in 2009?
Give a very brief answer. 1.14. What is the ratio of the Emissions(in percent) of Cote d'Ivoire in 2007 to that in 2009?
Provide a short and direct response. 0.88. What is the ratio of the Emissions(in percent) in Georgia in 2007 to that in 2009?
Provide a short and direct response. 1.4. What is the ratio of the Emissions(in percent) of Slovenia in 2007 to that in 2009?
Your answer should be compact. 1.04. What is the ratio of the Emissions(in percent) in Bulgaria in 2007 to that in 2010?
Offer a terse response. 1.11. What is the ratio of the Emissions(in percent) of Cote d'Ivoire in 2007 to that in 2010?
Ensure brevity in your answer.  0.81. What is the ratio of the Emissions(in percent) in Georgia in 2007 to that in 2010?
Ensure brevity in your answer.  1.59. What is the ratio of the Emissions(in percent) of Slovenia in 2007 to that in 2010?
Give a very brief answer. 1.01. What is the ratio of the Emissions(in percent) in Bulgaria in 2008 to that in 2009?
Keep it short and to the point. 1.13. What is the ratio of the Emissions(in percent) of Cote d'Ivoire in 2008 to that in 2009?
Your answer should be very brief. 0.93. What is the ratio of the Emissions(in percent) of Georgia in 2008 to that in 2009?
Offer a very short reply. 1.22. What is the ratio of the Emissions(in percent) of Slovenia in 2008 to that in 2009?
Make the answer very short. 0.94. What is the ratio of the Emissions(in percent) in Bulgaria in 2008 to that in 2010?
Your response must be concise. 1.1. What is the ratio of the Emissions(in percent) of Cote d'Ivoire in 2008 to that in 2010?
Offer a terse response. 0.86. What is the ratio of the Emissions(in percent) in Georgia in 2008 to that in 2010?
Keep it short and to the point. 1.38. What is the ratio of the Emissions(in percent) in Slovenia in 2008 to that in 2010?
Ensure brevity in your answer.  0.91. What is the ratio of the Emissions(in percent) of Bulgaria in 2009 to that in 2010?
Your response must be concise. 0.97. What is the ratio of the Emissions(in percent) of Cote d'Ivoire in 2009 to that in 2010?
Provide a succinct answer. 0.92. What is the ratio of the Emissions(in percent) in Georgia in 2009 to that in 2010?
Your answer should be very brief. 1.13. What is the difference between the highest and the second highest Emissions(in percent) of Bulgaria?
Provide a short and direct response. 0.17. What is the difference between the highest and the second highest Emissions(in percent) in Cote d'Ivoire?
Offer a terse response. 4.06. What is the difference between the highest and the second highest Emissions(in percent) of Georgia?
Make the answer very short. 4.13. What is the difference between the highest and the second highest Emissions(in percent) of Slovenia?
Give a very brief answer. 0.34. What is the difference between the highest and the lowest Emissions(in percent) of Bulgaria?
Ensure brevity in your answer.  1.97. What is the difference between the highest and the lowest Emissions(in percent) of Cote d'Ivoire?
Ensure brevity in your answer.  12.66. What is the difference between the highest and the lowest Emissions(in percent) of Georgia?
Your answer should be compact. 27.04. What is the difference between the highest and the lowest Emissions(in percent) in Slovenia?
Your response must be concise. 1.73. 